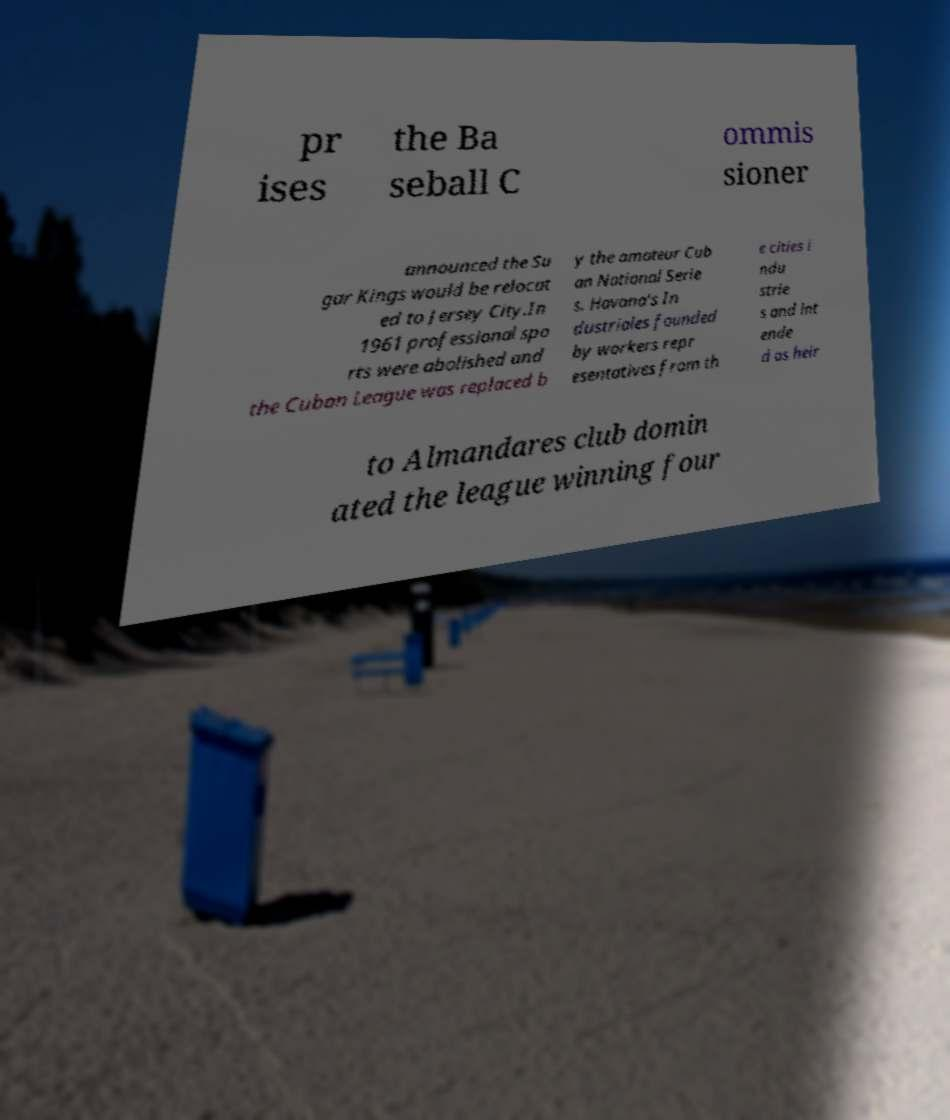Can you accurately transcribe the text from the provided image for me? pr ises the Ba seball C ommis sioner announced the Su gar Kings would be relocat ed to Jersey City.In 1961 professional spo rts were abolished and the Cuban League was replaced b y the amateur Cub an National Serie s. Havana's In dustriales founded by workers repr esentatives from th e cities i ndu strie s and int ende d as heir to Almandares club domin ated the league winning four 